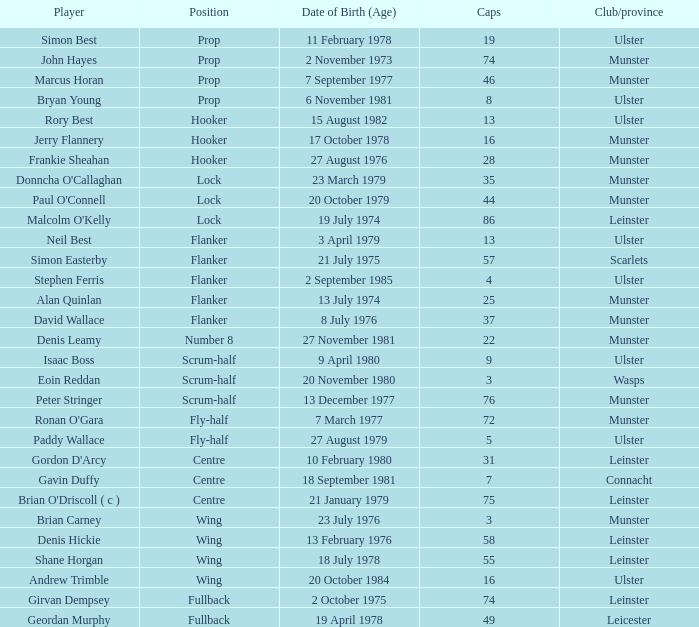Which Ulster player has fewer than 49 caps and plays the wing position? Andrew Trimble. 